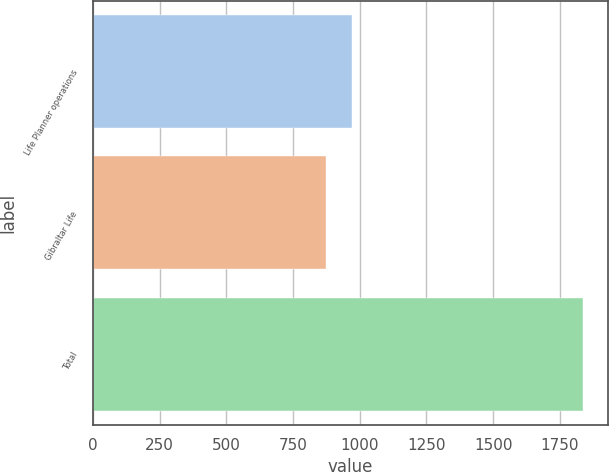<chart> <loc_0><loc_0><loc_500><loc_500><bar_chart><fcel>Life Planner operations<fcel>Gibraltar Life<fcel>Total<nl><fcel>970.4<fcel>874<fcel>1838<nl></chart> 